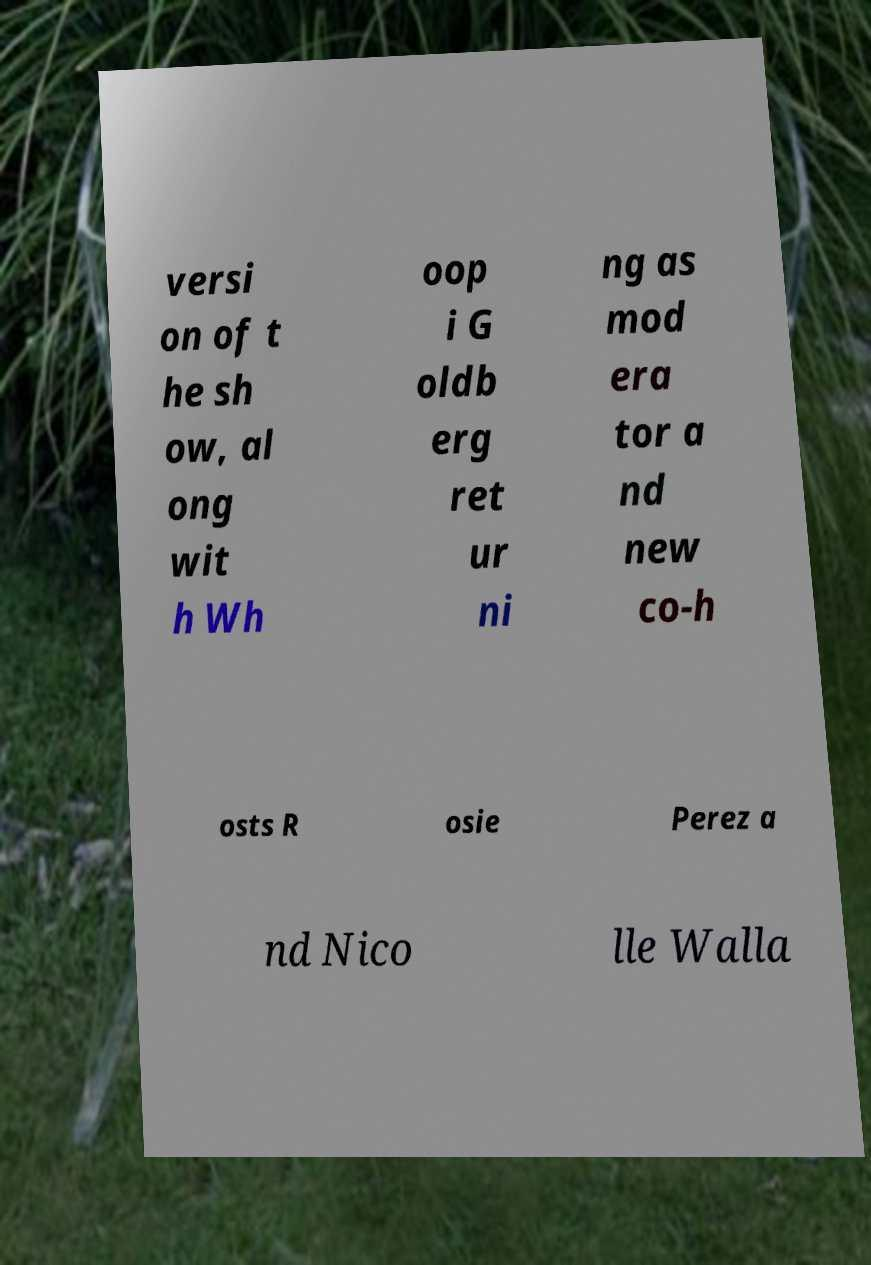Please read and relay the text visible in this image. What does it say? versi on of t he sh ow, al ong wit h Wh oop i G oldb erg ret ur ni ng as mod era tor a nd new co-h osts R osie Perez a nd Nico lle Walla 